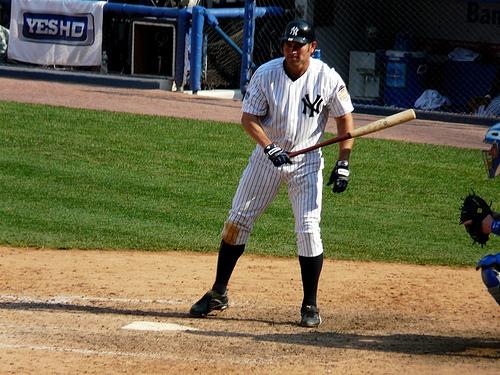Are these professional players?
Concise answer only. Yes. Is this person pants dirty?
Keep it brief. Yes. Did he hit a homerun?
Concise answer only. No. What team is this player on?
Short answer required. Yankees. Is this a little league game?
Be succinct. No. What sport is being played?
Keep it brief. Baseball. 